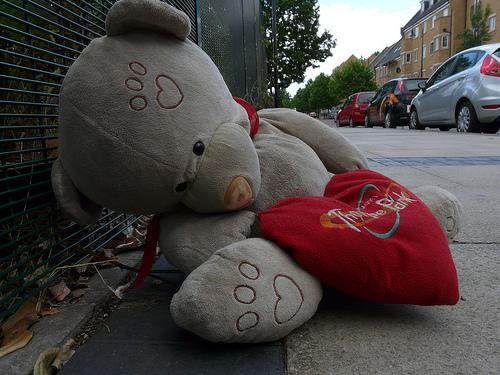Question: what is the object portrayed here?
Choices:
A. A Barbie doll.
B. A stuffed animal.
C. A toy car.
D. A box of Legos.
Answer with the letter. Answer: B Question: how was this picture taken?
Choices:
A. From above.
B. At the eye level.
C. Camera.
D. Cell phone.
Answer with the letter. Answer: C Question: when was this picture taken?
Choices:
A. Evening.
B. At dusk.
C. Daytime.
D. At sunrise.
Answer with the letter. Answer: C Question: what is the metal object behind the stuffed animal?
Choices:
A. A toy car.
B. A bed's  headboard.
C. Metal railing.
D. A pipe.
Answer with the letter. Answer: C Question: where was this picture taken?
Choices:
A. In the alley.
B. On a street.
C. On a highway.
D. On a bridge.
Answer with the letter. Answer: B 